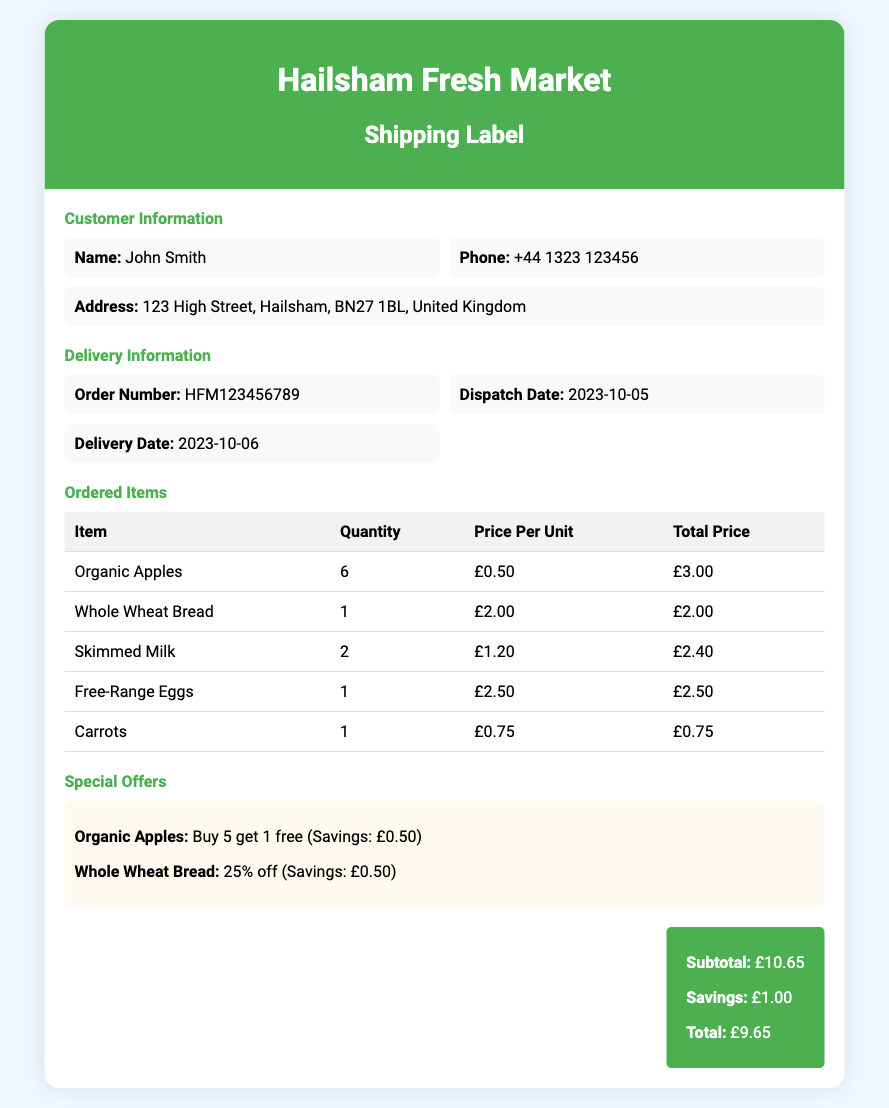What is the name of the customer? The customer's name is specified in the document under Customer Information.
Answer: John Smith What is the delivery date? The delivery date is indicated in the Delivery Information section.
Answer: 2023-10-06 What is the order number? The order number can be found in the Delivery Information section.
Answer: HFM123456789 How many Organic Apples were ordered? The quantity of Organic Apples is mentioned in the Ordered Items table.
Answer: 6 What savings are listed for Whole Wheat Bread? The savings for Whole Wheat Bread can be found in the Special Offers section.
Answer: £0.50 What is the subtotal of the order? The subtotal is provided at the end of the document under the total section.
Answer: £10.65 What is the total price after savings? The total price after savings is detailed in the total section.
Answer: £9.65 What date was the order dispatched? The dispatch date is shown in the Delivery Information section.
Answer: 2023-10-05 What percentage off is offered on Whole Wheat Bread? The discount percentage for Whole Wheat Bread is mentioned in the Special Offers section.
Answer: 25% off 